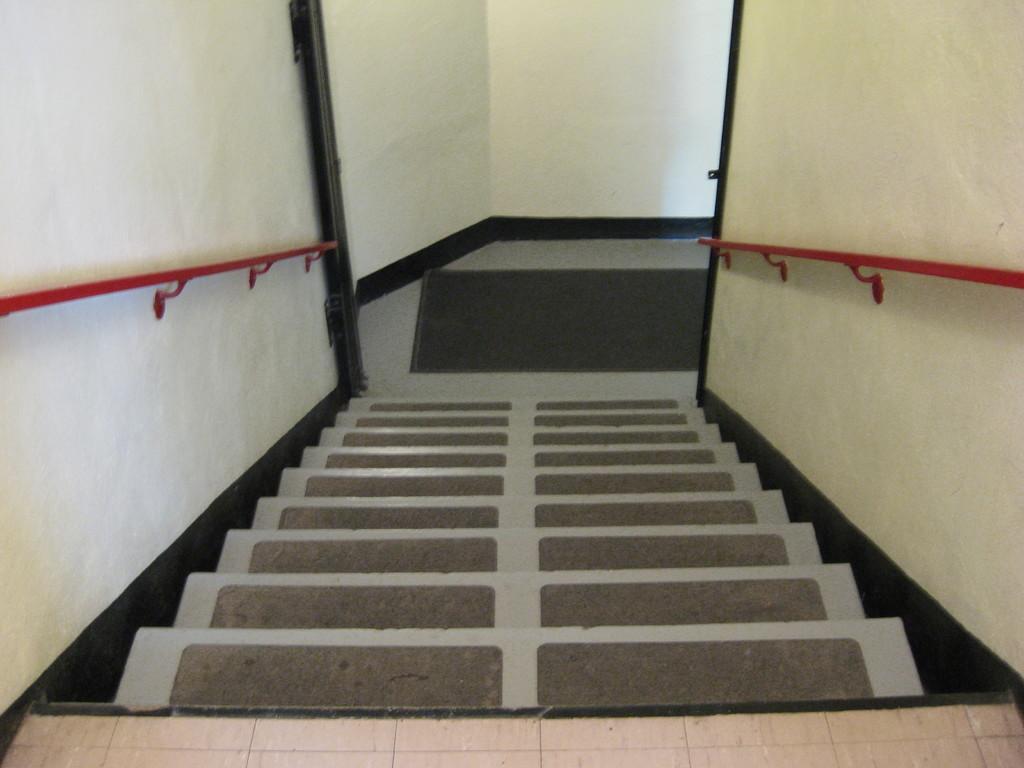How would you summarize this image in a sentence or two? In this image there are steps in the middle. On the steps there are mats. There are iron rods on either side of the steps. At the top there is a wall. On the floor there is a mat. 